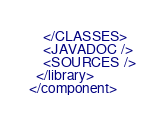Convert code to text. <code><loc_0><loc_0><loc_500><loc_500><_XML_>    </CLASSES>
    <JAVADOC />
    <SOURCES />
  </library>
</component></code> 